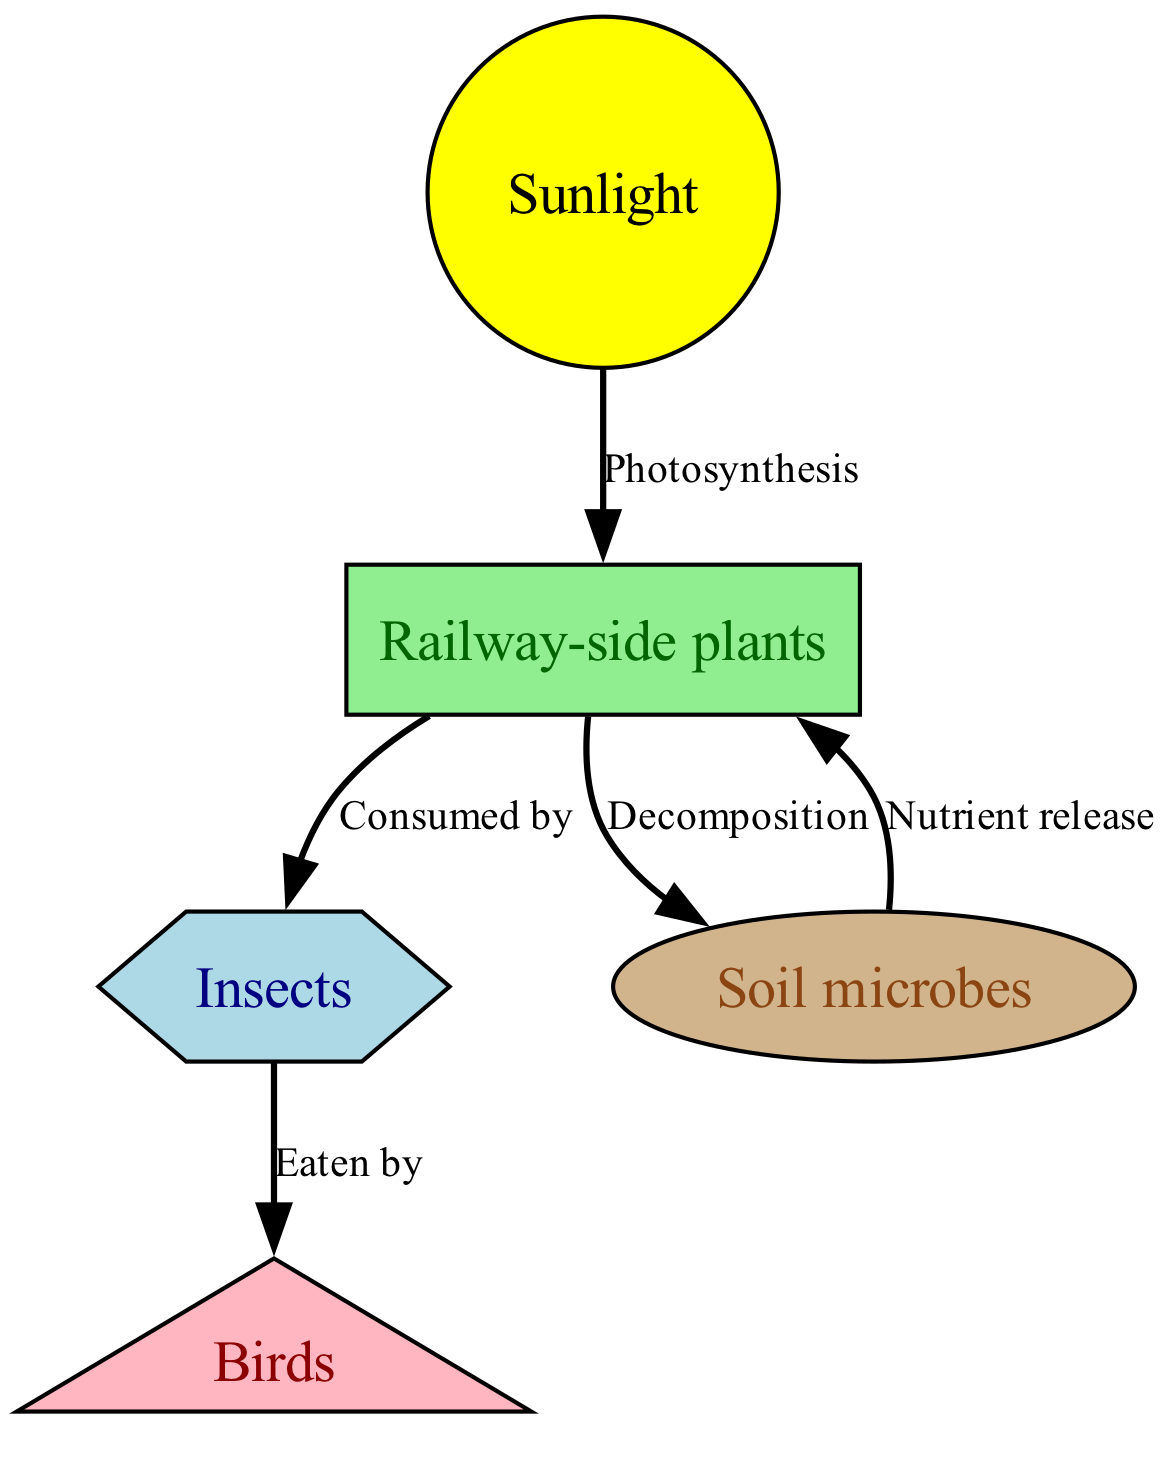What is the primary source of energy for railway-side plants? The diagram shows that sunlight is the primary source of energy for railway-side plants, indicated by the directed edge from 'sunlight' to 'railside_plants' labeled 'Photosynthesis.'
Answer: Sunlight How many nodes are there in the diagram? By counting the distinct entities presented in the nodes section, we find there are five entities: sunlight, railway-side plants, insects, birds, and soil microbes.
Answer: 5 What do insects consume according to the diagram? The directed edge from 'railside_plants' to 'insects' is labeled 'Consumed by,' indicating that insects consume railway-side plants.
Answer: Railway-side plants What processes do soil microbes release nutrients for? The directed edge from 'soil_microbes' to 'railside_plants' is labeled 'Nutrient release,' showing that soil microbes release nutrients that benefit railway-side plants.
Answer: Railway-side plants What do birds eat according to the food chain? The diagram indicates that insects are the prey of birds, as shown by the edge from 'insects' to 'birds' labeled 'Eaten by.'
Answer: Insects Which node receives nutrients from the decomposition process? The edge labeled 'Decomposition' from 'railside_plants' to 'soil_microbes' indicates that soil microbes are involved in nutrient cycling through decomposition.
Answer: Soil microbes What form of energy transfer is represented from 'sunlight' to 'railside plants'? The edge labeled 'Photosynthesis' demonstrates the conversion of energy from sunlight into stored chemical energy in railway-side plants.
Answer: Photosynthesis What is the relationship between 'soil microbes' and 'railside plants'? Soil microbes provide nutrients back to railway-side plants as indicated by the directed edge labeled 'Nutrient release' from 'soil_microbes' to 'railside_plants.'
Answer: Nutrient release 